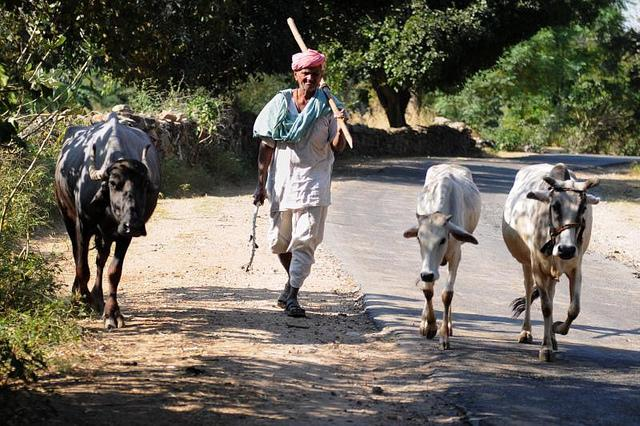What color is the turban worn by the man herding the cows? Please explain your reasoning. red. The turban sits on top of his head in this color. 